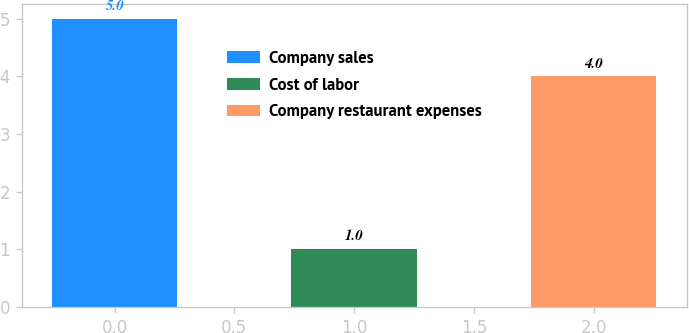Convert chart. <chart><loc_0><loc_0><loc_500><loc_500><bar_chart><fcel>Company sales<fcel>Cost of labor<fcel>Company restaurant expenses<nl><fcel>5<fcel>1<fcel>4<nl></chart> 